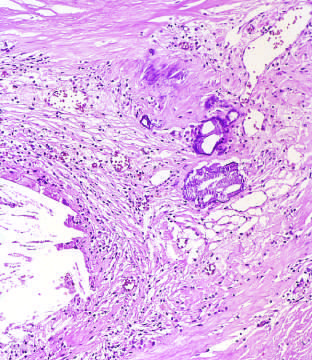did the cause of reversible injury show scattered inflammatory cells, calcification arrowheads, and neovascularization?
Answer the question using a single word or phrase. No 